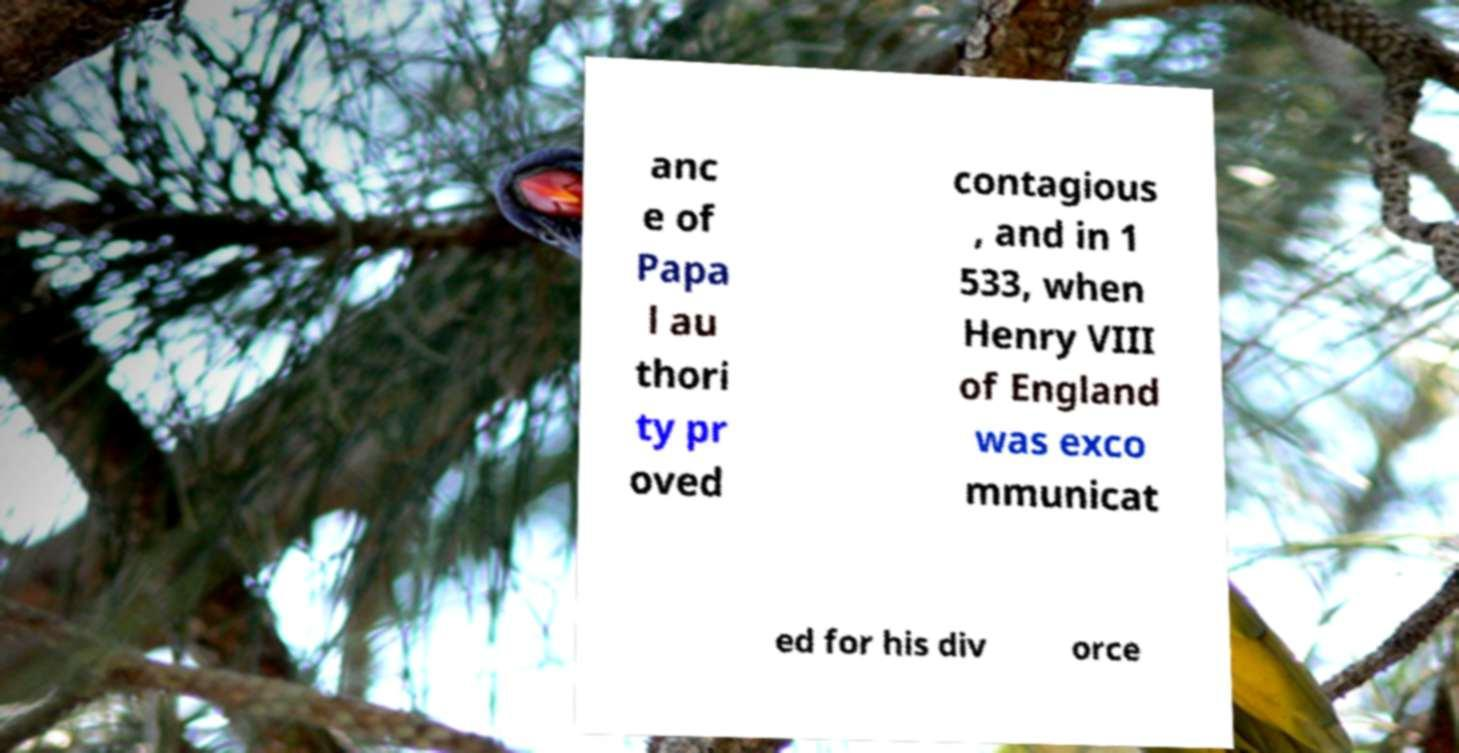Please read and relay the text visible in this image. What does it say? anc e of Papa l au thori ty pr oved contagious , and in 1 533, when Henry VIII of England was exco mmunicat ed for his div orce 